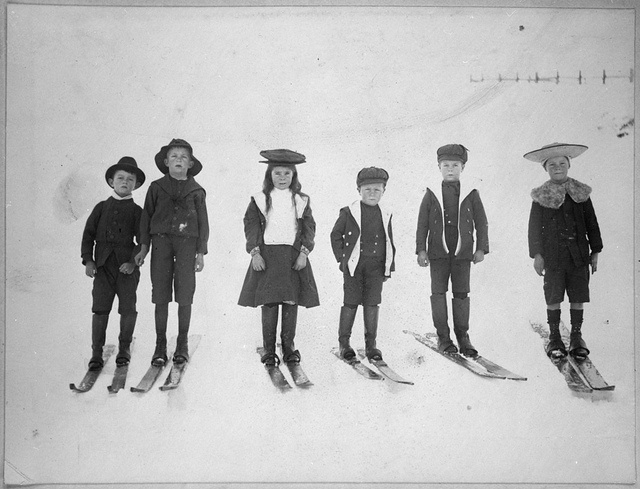Describe the objects in this image and their specific colors. I can see people in darkgray, gray, lightgray, and black tones, people in darkgray, black, gray, and lightgray tones, people in darkgray, black, gray, and lightgray tones, people in darkgray, black, gray, and lightgray tones, and people in darkgray, gray, black, and lightgray tones in this image. 